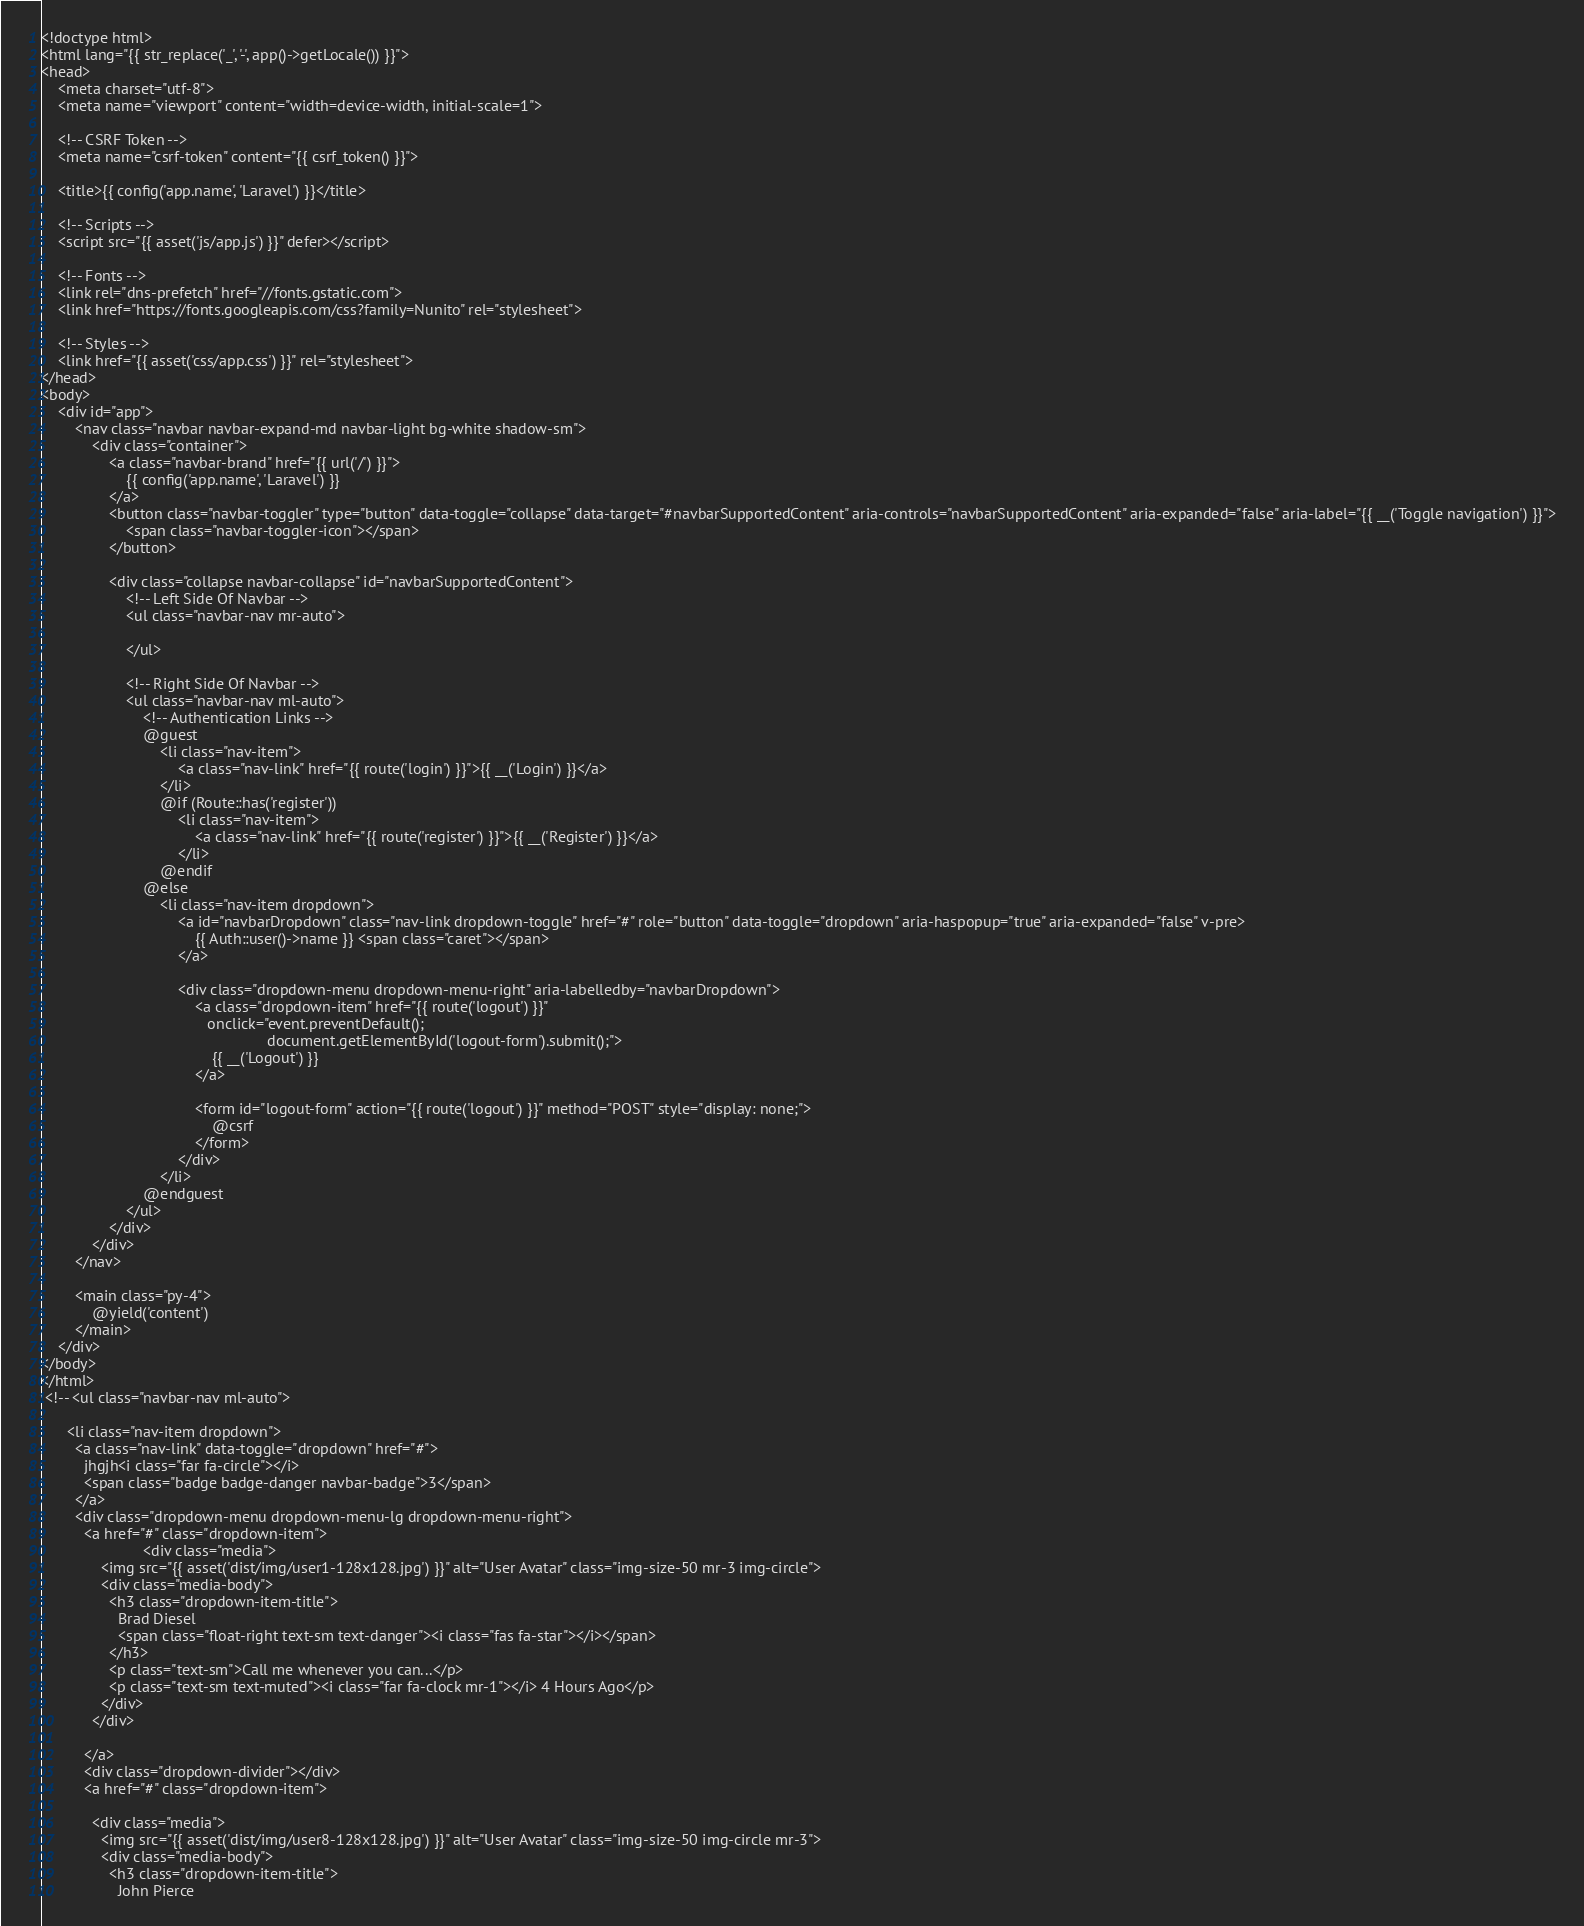Convert code to text. <code><loc_0><loc_0><loc_500><loc_500><_PHP_><!doctype html>
<html lang="{{ str_replace('_', '-', app()->getLocale()) }}">
<head>
    <meta charset="utf-8">
    <meta name="viewport" content="width=device-width, initial-scale=1">

    <!-- CSRF Token -->
    <meta name="csrf-token" content="{{ csrf_token() }}">

    <title>{{ config('app.name', 'Laravel') }}</title>

    <!-- Scripts -->
    <script src="{{ asset('js/app.js') }}" defer></script>

    <!-- Fonts -->
    <link rel="dns-prefetch" href="//fonts.gstatic.com">
    <link href="https://fonts.googleapis.com/css?family=Nunito" rel="stylesheet">

    <!-- Styles -->
    <link href="{{ asset('css/app.css') }}" rel="stylesheet">
</head>
<body>
    <div id="app">
        <nav class="navbar navbar-expand-md navbar-light bg-white shadow-sm">
            <div class="container">
                <a class="navbar-brand" href="{{ url('/') }}">
                    {{ config('app.name', 'Laravel') }}
                </a>
                <button class="navbar-toggler" type="button" data-toggle="collapse" data-target="#navbarSupportedContent" aria-controls="navbarSupportedContent" aria-expanded="false" aria-label="{{ __('Toggle navigation') }}">
                    <span class="navbar-toggler-icon"></span>
                </button>

                <div class="collapse navbar-collapse" id="navbarSupportedContent">
                    <!-- Left Side Of Navbar -->
                    <ul class="navbar-nav mr-auto">

                    </ul>

                    <!-- Right Side Of Navbar -->
                    <ul class="navbar-nav ml-auto">
                        <!-- Authentication Links -->
                        @guest
                            <li class="nav-item">
                                <a class="nav-link" href="{{ route('login') }}">{{ __('Login') }}</a>
                            </li>
                            @if (Route::has('register'))
                                <li class="nav-item">
                                    <a class="nav-link" href="{{ route('register') }}">{{ __('Register') }}</a>
                                </li>
                            @endif
                        @else
                            <li class="nav-item dropdown">
                                <a id="navbarDropdown" class="nav-link dropdown-toggle" href="#" role="button" data-toggle="dropdown" aria-haspopup="true" aria-expanded="false" v-pre>
                                    {{ Auth::user()->name }} <span class="caret"></span>
                                </a>

                                <div class="dropdown-menu dropdown-menu-right" aria-labelledby="navbarDropdown">
                                    <a class="dropdown-item" href="{{ route('logout') }}"
                                       onclick="event.preventDefault();
                                                     document.getElementById('logout-form').submit();">
                                        {{ __('Logout') }}
                                    </a>

                                    <form id="logout-form" action="{{ route('logout') }}" method="POST" style="display: none;">
                                        @csrf
                                    </form>
                                </div>
                            </li>
                        @endguest
                    </ul>
                </div>
            </div>
        </nav>

        <main class="py-4">
            @yield('content')
        </main>
    </div>
</body>
</html>
 <!-- <ul class="navbar-nav ml-auto">
     
      <li class="nav-item dropdown">
        <a class="nav-link" data-toggle="dropdown" href="#">
          jhgjh<i class="far fa-circle"></i>
          <span class="badge badge-danger navbar-badge">3</span>
        </a>
        <div class="dropdown-menu dropdown-menu-lg dropdown-menu-right">
          <a href="#" class="dropdown-item">
                        <div class="media">
              <img src="{{ asset('dist/img/user1-128x128.jpg') }}" alt="User Avatar" class="img-size-50 mr-3 img-circle">
              <div class="media-body">
                <h3 class="dropdown-item-title">
                  Brad Diesel
                  <span class="float-right text-sm text-danger"><i class="fas fa-star"></i></span>
                </h3>
                <p class="text-sm">Call me whenever you can...</p>
                <p class="text-sm text-muted"><i class="far fa-clock mr-1"></i> 4 Hours Ago</p>
              </div>
            </div>
          
          </a>
          <div class="dropdown-divider"></div>
          <a href="#" class="dropdown-item">
            
            <div class="media">
              <img src="{{ asset('dist/img/user8-128x128.jpg') }}" alt="User Avatar" class="img-size-50 img-circle mr-3">
              <div class="media-body">
                <h3 class="dropdown-item-title">
                  John Pierce</code> 